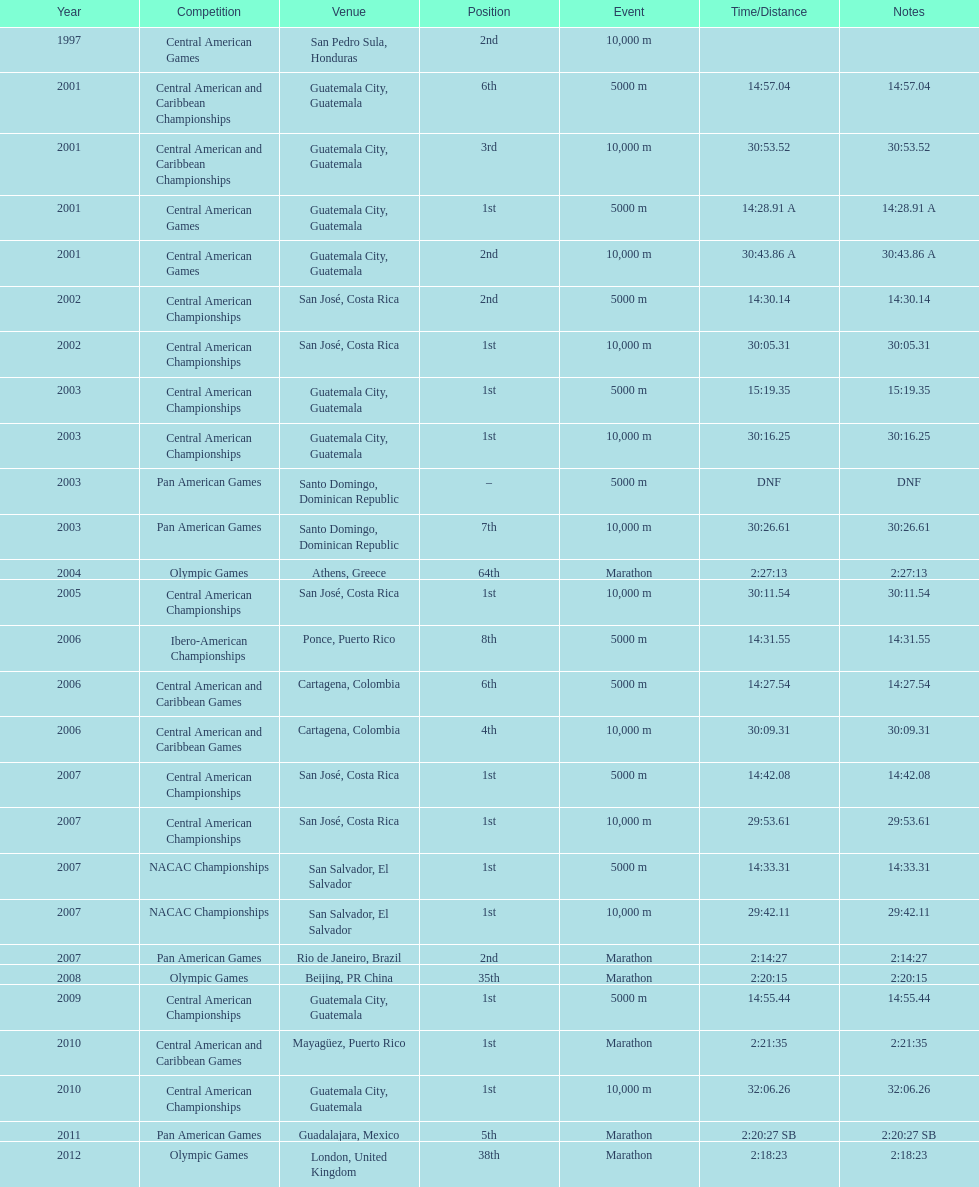Where was the only 64th position held? Athens, Greece. Could you parse the entire table? {'header': ['Year', 'Competition', 'Venue', 'Position', 'Event', 'Time/Distance', 'Notes'], 'rows': [['1997', 'Central American Games', 'San Pedro Sula, Honduras', '2nd', '10,000 m', '', ''], ['2001', 'Central American and Caribbean Championships', 'Guatemala City, Guatemala', '6th', '5000 m', '14:57.04', '14:57.04'], ['2001', 'Central American and Caribbean Championships', 'Guatemala City, Guatemala', '3rd', '10,000 m', '30:53.52', '30:53.52'], ['2001', 'Central American Games', 'Guatemala City, Guatemala', '1st', '5000 m', '14:28.91 A', '14:28.91 A'], ['2001', 'Central American Games', 'Guatemala City, Guatemala', '2nd', '10,000 m', '30:43.86 A', '30:43.86 A'], ['2002', 'Central American Championships', 'San José, Costa Rica', '2nd', '5000 m', '14:30.14', '14:30.14'], ['2002', 'Central American Championships', 'San José, Costa Rica', '1st', '10,000 m', '30:05.31', '30:05.31'], ['2003', 'Central American Championships', 'Guatemala City, Guatemala', '1st', '5000 m', '15:19.35', '15:19.35'], ['2003', 'Central American Championships', 'Guatemala City, Guatemala', '1st', '10,000 m', '30:16.25', '30:16.25'], ['2003', 'Pan American Games', 'Santo Domingo, Dominican Republic', '–', '5000 m', 'DNF', 'DNF'], ['2003', 'Pan American Games', 'Santo Domingo, Dominican Republic', '7th', '10,000 m', '30:26.61', '30:26.61'], ['2004', 'Olympic Games', 'Athens, Greece', '64th', 'Marathon', '2:27:13', '2:27:13'], ['2005', 'Central American Championships', 'San José, Costa Rica', '1st', '10,000 m', '30:11.54', '30:11.54'], ['2006', 'Ibero-American Championships', 'Ponce, Puerto Rico', '8th', '5000 m', '14:31.55', '14:31.55'], ['2006', 'Central American and Caribbean Games', 'Cartagena, Colombia', '6th', '5000 m', '14:27.54', '14:27.54'], ['2006', 'Central American and Caribbean Games', 'Cartagena, Colombia', '4th', '10,000 m', '30:09.31', '30:09.31'], ['2007', 'Central American Championships', 'San José, Costa Rica', '1st', '5000 m', '14:42.08', '14:42.08'], ['2007', 'Central American Championships', 'San José, Costa Rica', '1st', '10,000 m', '29:53.61', '29:53.61'], ['2007', 'NACAC Championships', 'San Salvador, El Salvador', '1st', '5000 m', '14:33.31', '14:33.31'], ['2007', 'NACAC Championships', 'San Salvador, El Salvador', '1st', '10,000 m', '29:42.11', '29:42.11'], ['2007', 'Pan American Games', 'Rio de Janeiro, Brazil', '2nd', 'Marathon', '2:14:27', '2:14:27'], ['2008', 'Olympic Games', 'Beijing, PR China', '35th', 'Marathon', '2:20:15', '2:20:15'], ['2009', 'Central American Championships', 'Guatemala City, Guatemala', '1st', '5000 m', '14:55.44', '14:55.44'], ['2010', 'Central American and Caribbean Games', 'Mayagüez, Puerto Rico', '1st', 'Marathon', '2:21:35', '2:21:35'], ['2010', 'Central American Championships', 'Guatemala City, Guatemala', '1st', '10,000 m', '32:06.26', '32:06.26'], ['2011', 'Pan American Games', 'Guadalajara, Mexico', '5th', 'Marathon', '2:20:27 SB', '2:20:27 SB'], ['2012', 'Olympic Games', 'London, United Kingdom', '38th', 'Marathon', '2:18:23', '2:18:23']]} 